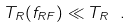<formula> <loc_0><loc_0><loc_500><loc_500>T _ { R } ( f _ { R F } ) \ll T _ { R } \ .</formula> 